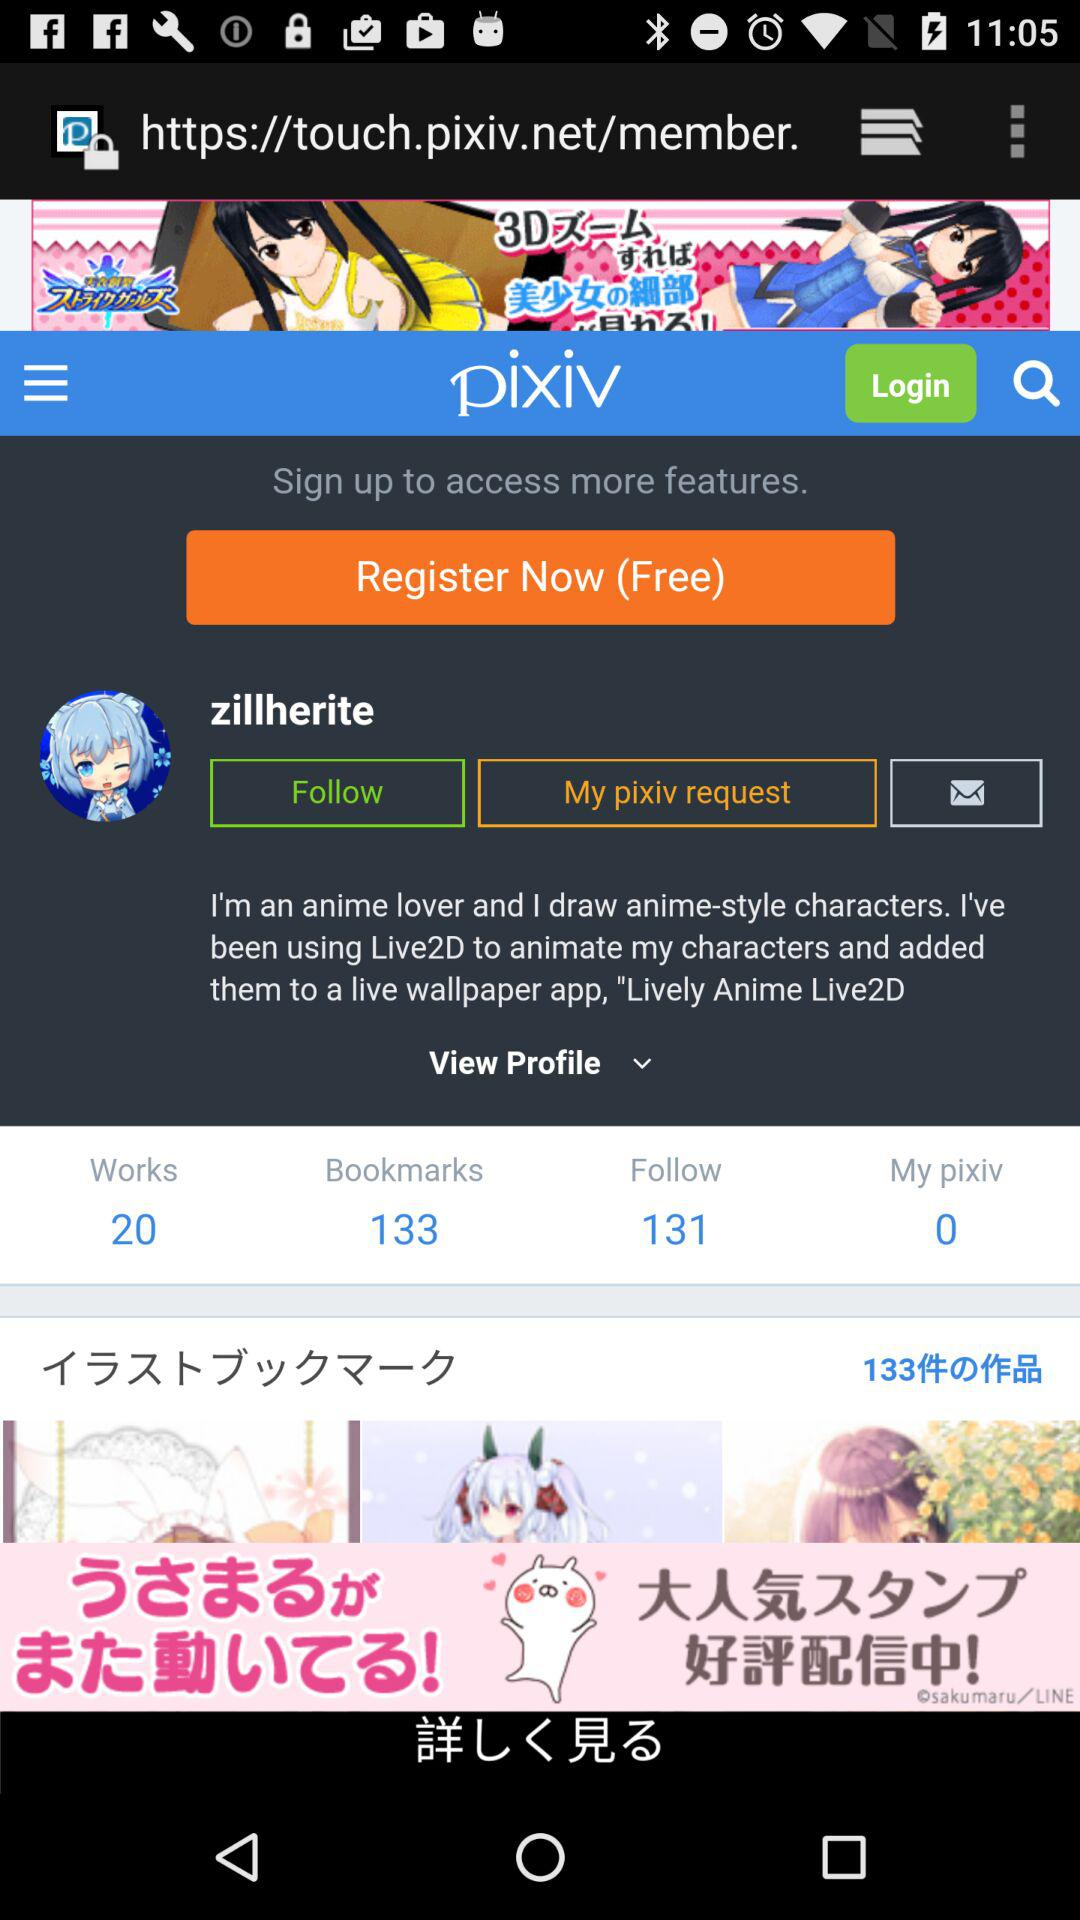How many followers are there? There are 131 followers. 